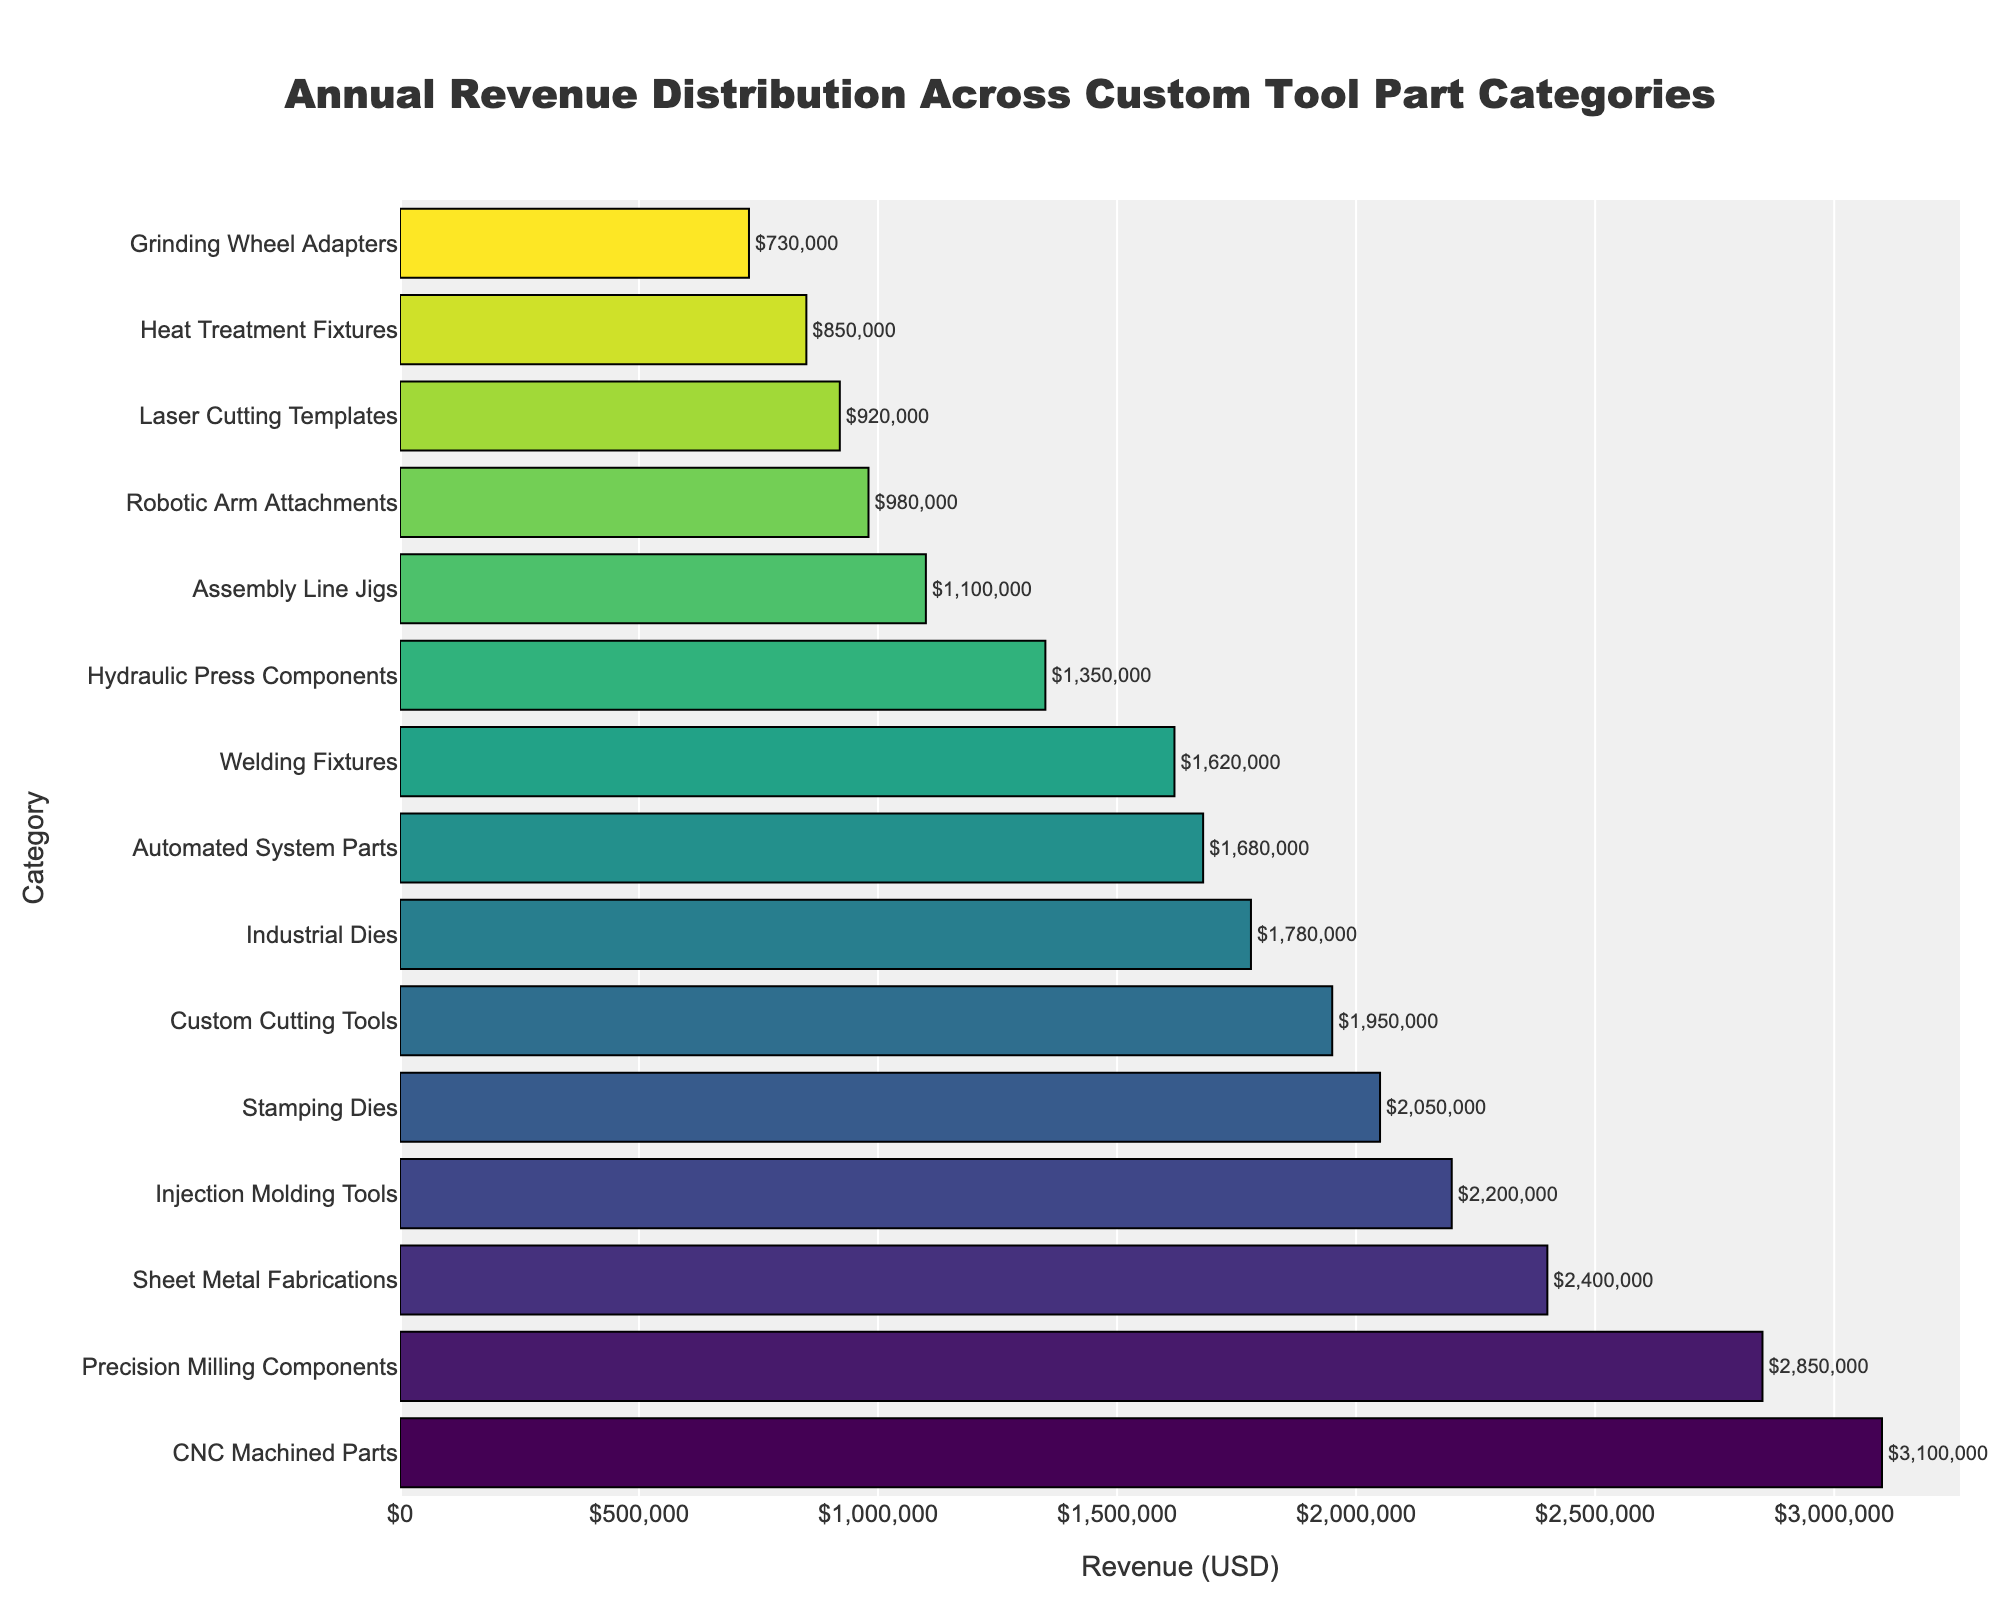What is the highest revenue category? The bar at the top of the sorted bar chart represents the highest revenue category. By examining the chart, we see that "CNC Machined Parts" has the longest bar, indicating the highest revenue.
Answer: CNC Machined Parts Which category has the lowest revenue? The bar at the bottom of the sorted bar chart represents the lowest revenue category. By checking the chart, we find that "Grinding Wheel Adapters" has the shortest bar, indicating the lowest revenue.
Answer: Grinding Wheel Adapters How much more revenue do CNC Machined Parts generate than Precision Milling Components? First, identify the revenue for each category from the chart. CNC Machined Parts generate $3,100,000, and Precision Milling Components generate $2,850,000. The difference is $3,100,000 - $2,850,000 = $250,000.
Answer: $250,000 What is the combined revenue of Welding Fixtures and Injection Molding Tools? Locate the revenue for each category: Welding Fixtures ($1,620,000) and Injection Molding Tools ($2,200,000). Add the revenues to get the combined total: $1,620,000 + $2,200,000 = $3,820,000.
Answer: $3,820,000 Which categories have revenues higher than $2,000,000? Identify all bars with a length exceeding the $2,000,000 mark. The categories that meet this criterion are CNC Machined Parts, Precision Milling Components, Custom Cutting Tools, and Injection Molding Tools.
Answer: CNC Machined Parts, Precision Milling Components, Custom Cutting Tools, Injection Molding Tools Which category is just below Custom Cutting Tools in terms of revenue? In the sorted bar chart, find the Custom Cutting Tools bar and then look at the bar immediately below it. The category below is Stamping Dies.
Answer: Stamping Dies What is the difference in revenue between the categories with the second and third highest revenues? Identify the second and third highest revenue categories, which are Precision Milling Components ($2,850,000) and Sheet Metal Fabrications ($2,400,000). The difference is $2,850,000 - $2,400,000 = $450,000.
Answer: $450,000 How many categories have a revenue between $1,000,000 and $2,000,000? Count the number of bars whose lengths fall between the $1,000,000 and $2,000,000 markers. Five categories meet this criterion: Welding Fixtures, Industrial Dies, Automated System Parts, Stamping Dies, and Assembly Line Jigs.
Answer: Five What proportion of the total revenue is generated by CNC Machined Parts? First, calculate the total revenue by summing all category revenues. Sum = $2,850,000 + $1,950,000 + $1,620,000 + $3,100,000 + $2,400,000 + $1,780,000 + $1,350,000 + $980,000 + $2,200,000 + $850,000 + $1,100,000 + $1,680,000 + $2,050,000 + $920,000 + $730,000 = $25,460,000. The proportion is CNC Machined Parts revenue divided by total revenue: $3,100,000 / $25,460,000 ≈ 0.122.
Answer: 0.122 Which two categories show the smallest difference in their revenues? Examine the lengths of adjacent bars on the sorted chart to find the smallest difference. The smallest difference is between Stamping Dies ($2,050,000) and Custom Cutting Tools ($1,950,000), with a difference of $2,050,000 - $1,950,000 = $100,000.
Answer: Stamping Dies and Custom Cutting Tools, $100,000 